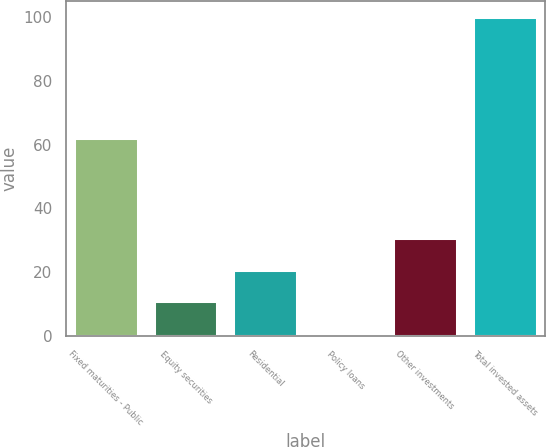<chart> <loc_0><loc_0><loc_500><loc_500><bar_chart><fcel>Fixed maturities - Public<fcel>Equity securities<fcel>Residential<fcel>Policy loans<fcel>Other investments<fcel>Total invested assets<nl><fcel>62<fcel>10.9<fcel>20.8<fcel>1<fcel>30.7<fcel>100<nl></chart> 